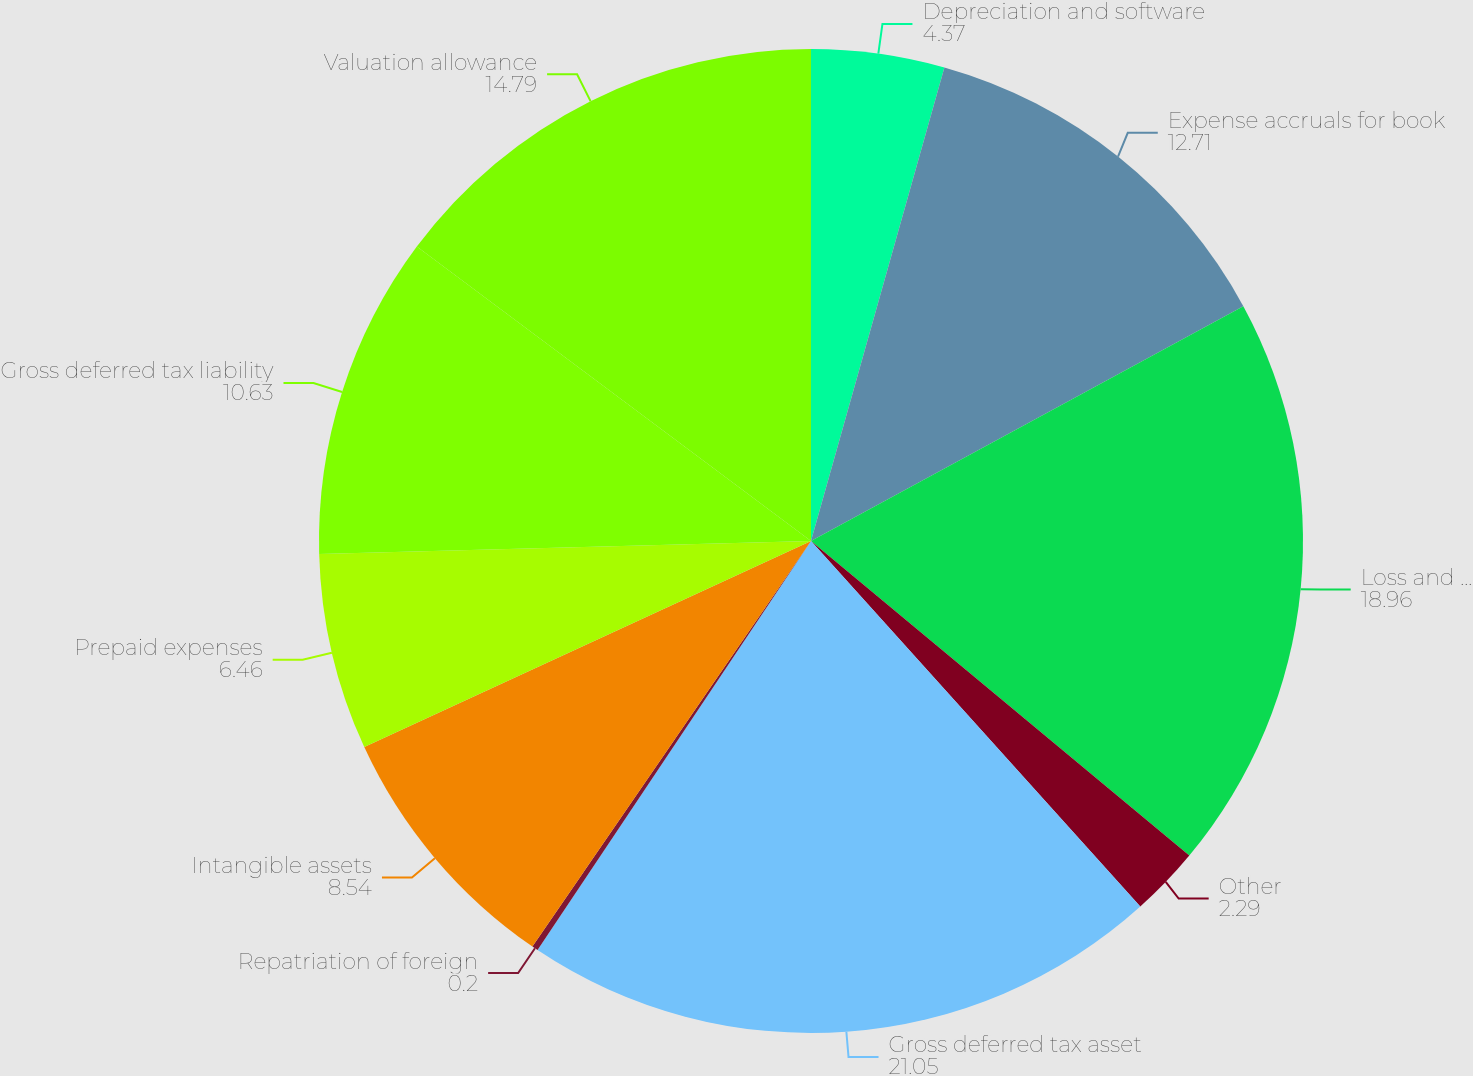Convert chart. <chart><loc_0><loc_0><loc_500><loc_500><pie_chart><fcel>Depreciation and software<fcel>Expense accruals for book<fcel>Loss and credit carryforwards<fcel>Other<fcel>Gross deferred tax asset<fcel>Repatriation of foreign<fcel>Intangible assets<fcel>Prepaid expenses<fcel>Gross deferred tax liability<fcel>Valuation allowance<nl><fcel>4.37%<fcel>12.71%<fcel>18.96%<fcel>2.29%<fcel>21.05%<fcel>0.2%<fcel>8.54%<fcel>6.46%<fcel>10.63%<fcel>14.79%<nl></chart> 